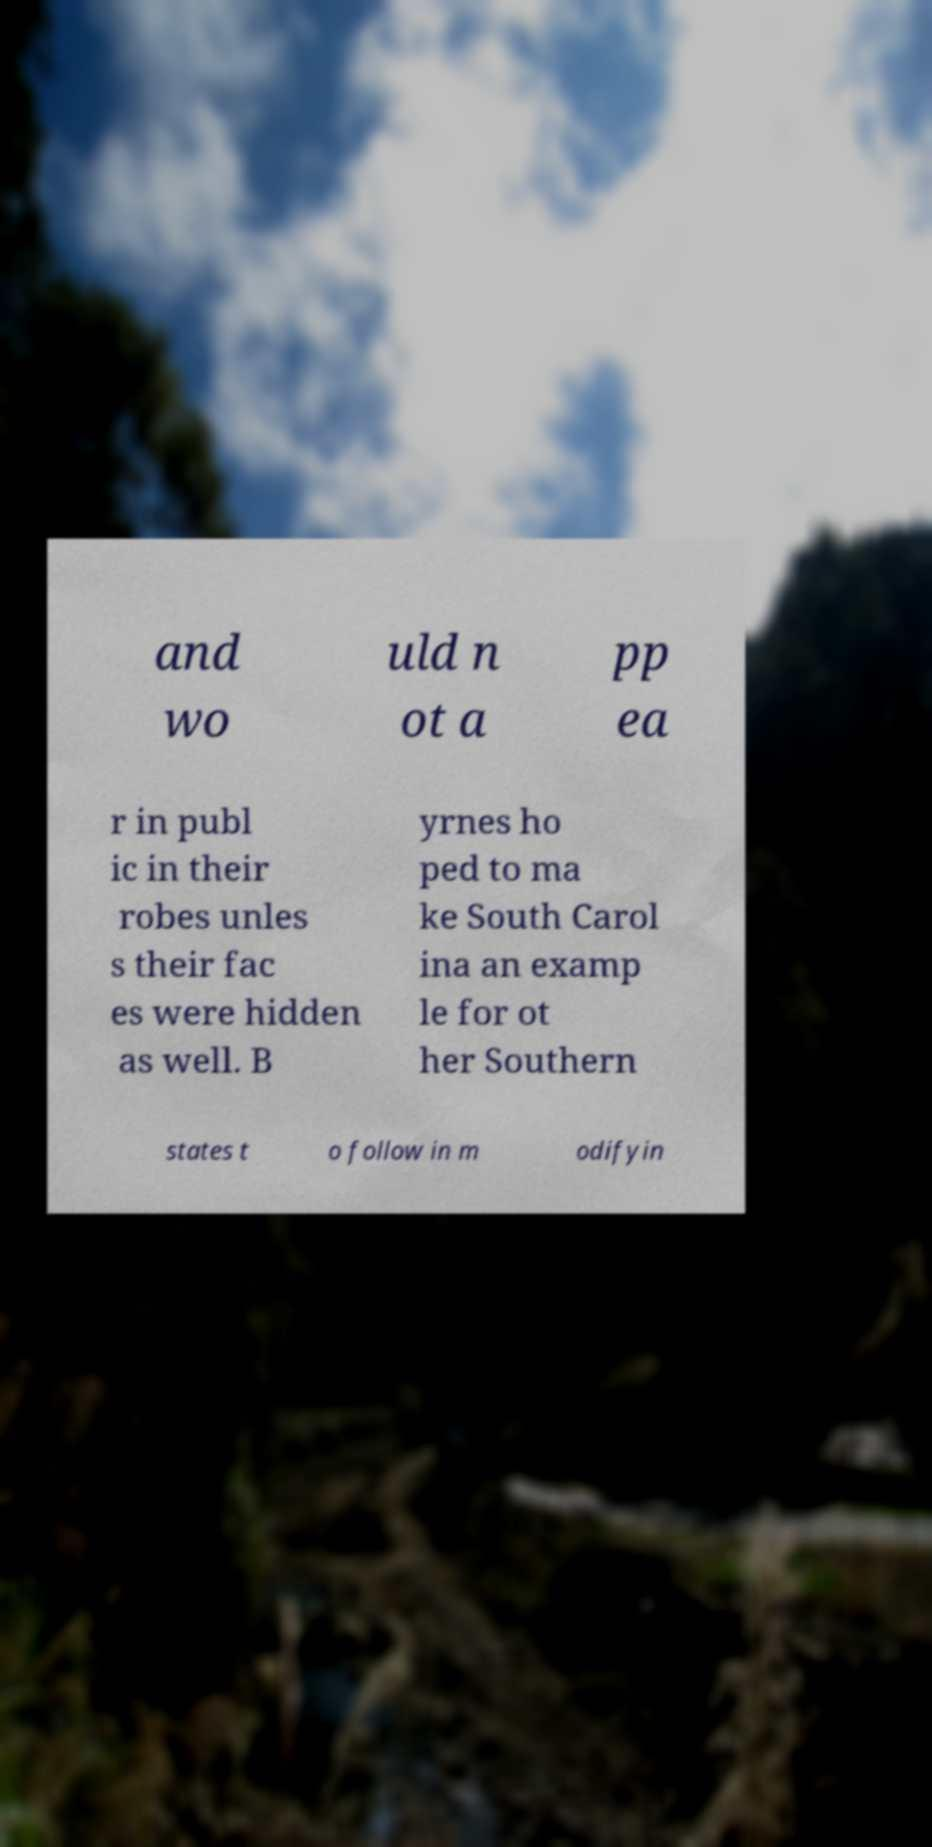For documentation purposes, I need the text within this image transcribed. Could you provide that? and wo uld n ot a pp ea r in publ ic in their robes unles s their fac es were hidden as well. B yrnes ho ped to ma ke South Carol ina an examp le for ot her Southern states t o follow in m odifyin 